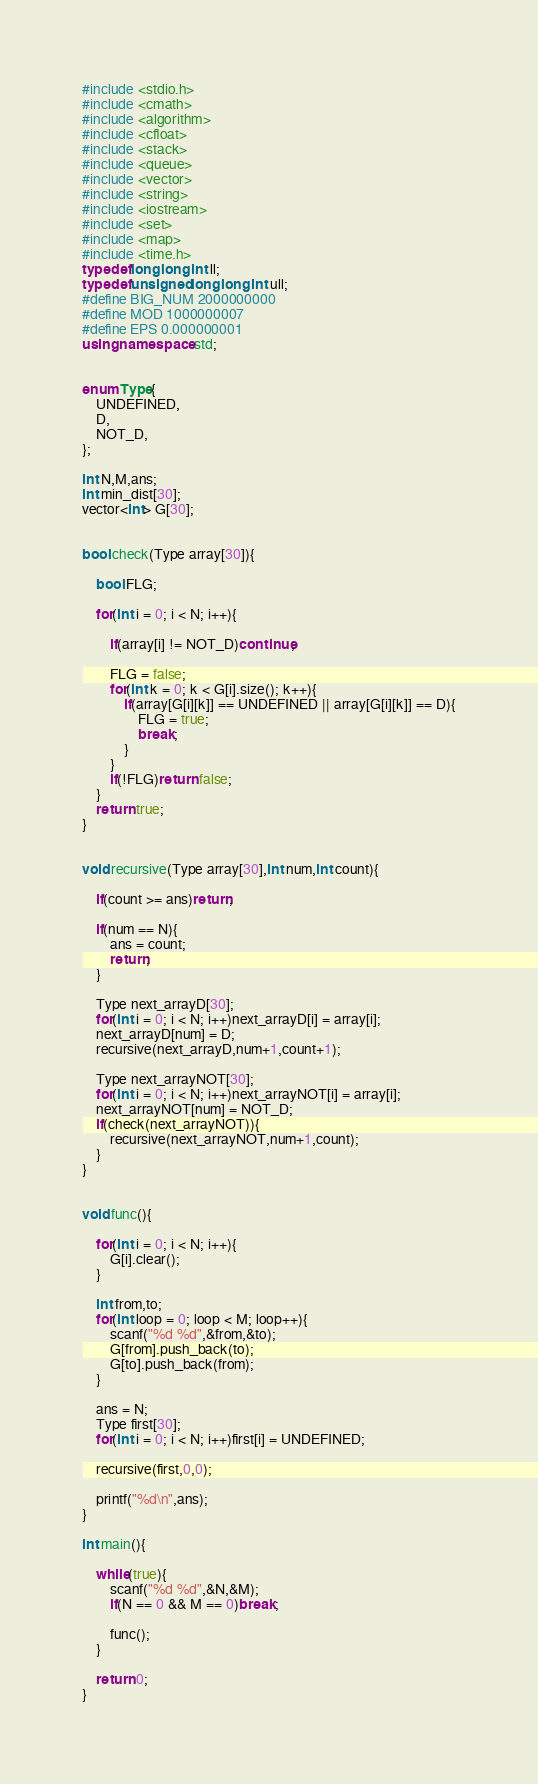Convert code to text. <code><loc_0><loc_0><loc_500><loc_500><_C++_>#include <stdio.h>
#include <cmath>
#include <algorithm>
#include <cfloat>
#include <stack>
#include <queue>
#include <vector>
#include <string>
#include <iostream>
#include <set>
#include <map>
#include <time.h>
typedef long long int ll;
typedef unsigned long long int ull;
#define BIG_NUM 2000000000
#define MOD 1000000007
#define EPS 0.000000001
using namespace std;


enum Type{
	UNDEFINED,
	D,
	NOT_D,
};

int N,M,ans;
int min_dist[30];
vector<int> G[30];


bool check(Type array[30]){

	bool FLG;

	for(int i = 0; i < N; i++){

		if(array[i] != NOT_D)continue;

		FLG = false;
		for(int k = 0; k < G[i].size(); k++){
			if(array[G[i][k]] == UNDEFINED || array[G[i][k]] == D){
				FLG = true;
				break;
			}
		}
		if(!FLG)return false;
	}
	return true;
}


void recursive(Type array[30],int num,int count){

	if(count >= ans)return;

	if(num == N){
		ans = count;
		return;
	}

	Type next_arrayD[30];
	for(int i = 0; i < N; i++)next_arrayD[i] = array[i];
	next_arrayD[num] = D;
	recursive(next_arrayD,num+1,count+1);

	Type next_arrayNOT[30];
	for(int i = 0; i < N; i++)next_arrayNOT[i] = array[i];
	next_arrayNOT[num] = NOT_D;
	if(check(next_arrayNOT)){
		recursive(next_arrayNOT,num+1,count);
	}
}


void func(){

	for(int i = 0; i < N; i++){
		G[i].clear();
	}

	int from,to;
	for(int loop = 0; loop < M; loop++){
		scanf("%d %d",&from,&to);
		G[from].push_back(to);
		G[to].push_back(from);
	}

	ans = N;
	Type first[30];
	for(int i = 0; i < N; i++)first[i] = UNDEFINED;

	recursive(first,0,0);

	printf("%d\n",ans);
}

int main(){

	while(true){
		scanf("%d %d",&N,&M);
		if(N == 0 && M == 0)break;

		func();
	}

	return 0;
}

</code> 